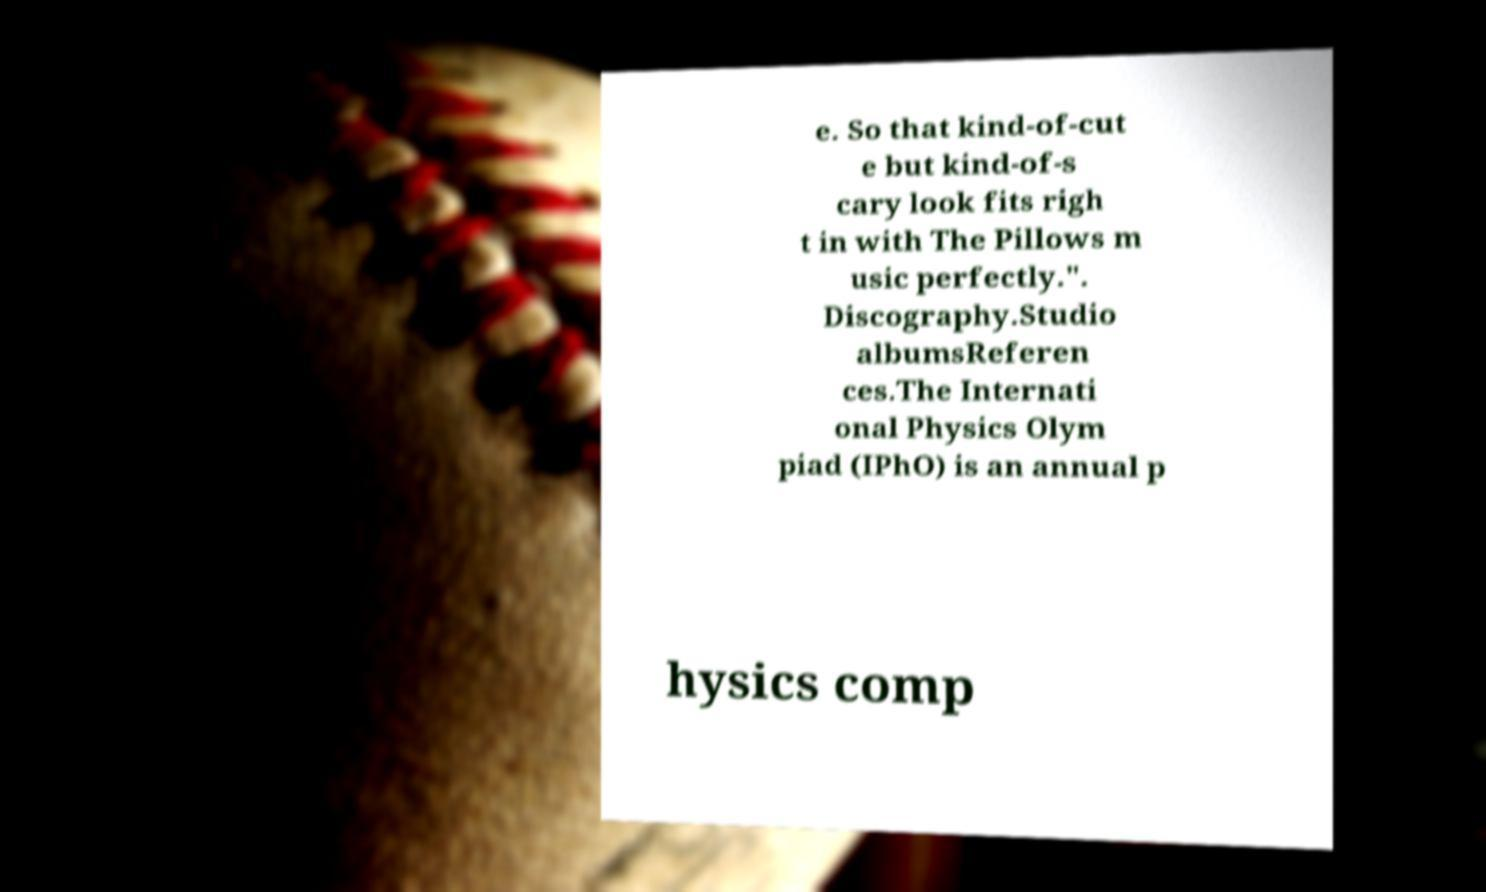Can you accurately transcribe the text from the provided image for me? e. So that kind-of-cut e but kind-of-s cary look fits righ t in with The Pillows m usic perfectly.". Discography.Studio albumsReferen ces.The Internati onal Physics Olym piad (IPhO) is an annual p hysics comp 